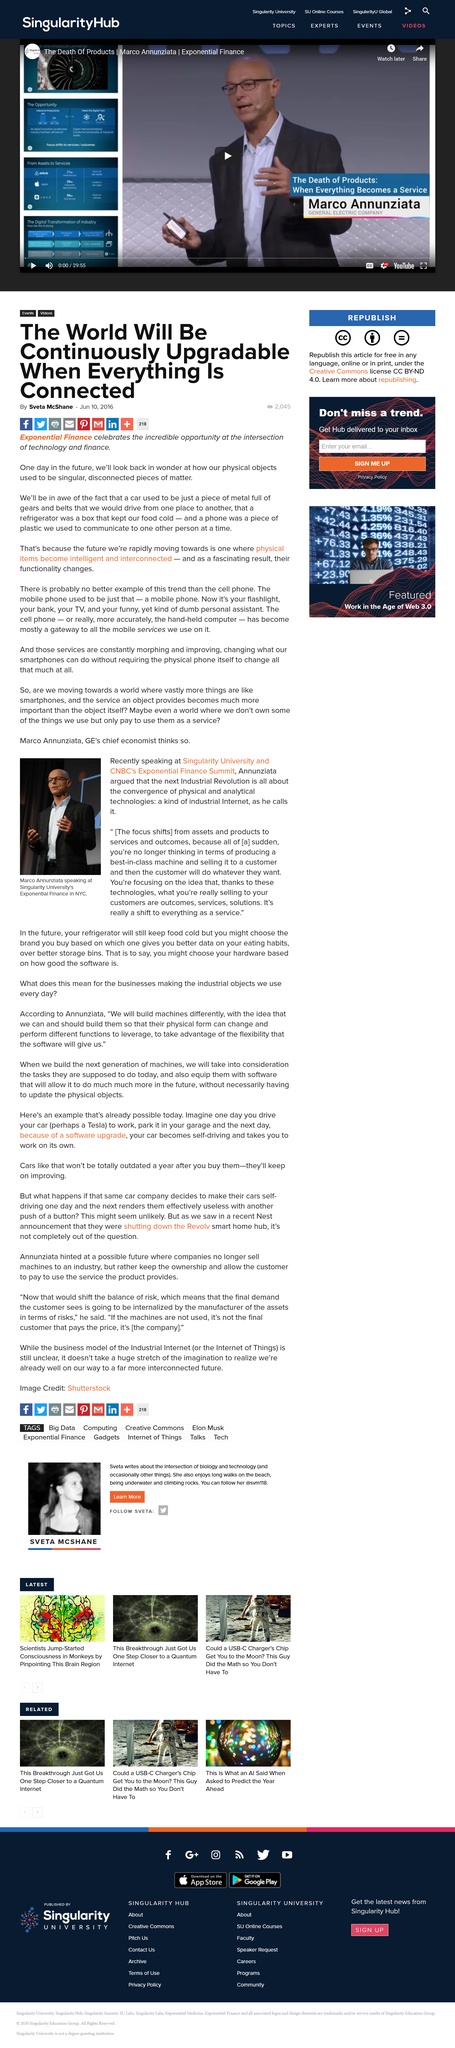Indicate a few pertinent items in this graphic. The author of this article is Sveta McShane. Yes, a mobile phone is an example of a physical item that has become intelligent or interconnected. Annunziata recently spoke at Singularity University and CNBC's Exponential Finance Summit. In the next Industrial Revolution, the focus will shift from assets and products to services and outcomes, as argued by Annunziata. Marco Annunziata is the chief economist of GE. 